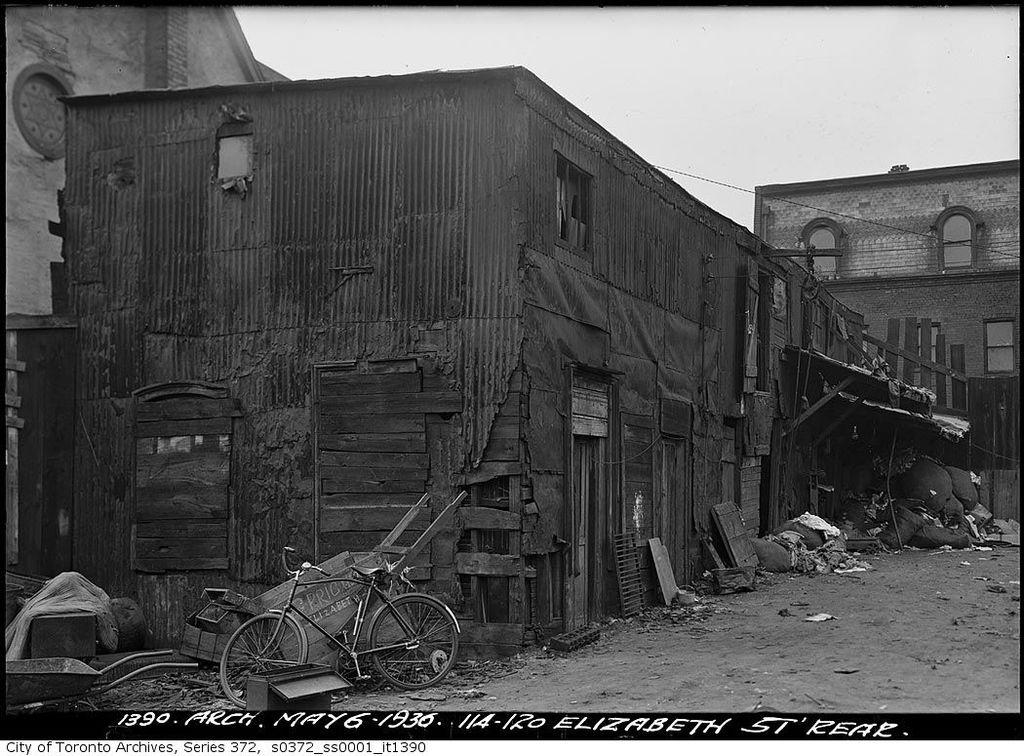What type of vehicle is in the image? There is a bicycle in the image. What other objects can be seen in the image? There are carts and boxes visible in the image. What type of structures are visible in the image? There are buildings with windows visible in the image. What is on the ground in the image? There are objects on the ground in the image. What can be seen in the background of the image? The sky is visible in the background of the image. What type of bone can be seen in the image? There is no bone present in the image. Can you describe the woman in the image? There is no woman present in the image. 